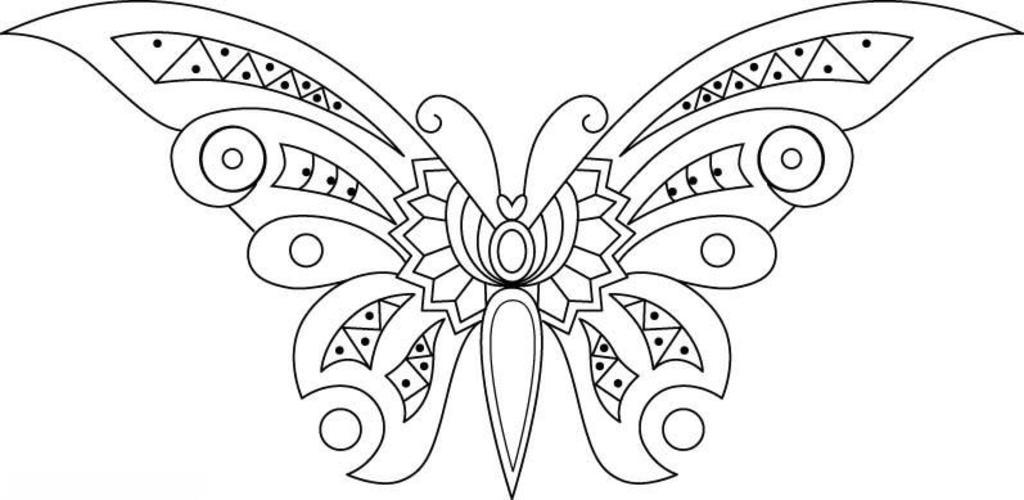What is depicted in the image? There is a sketch of a butterfly in the image. What type of linen is used to cover the cave in the image? There is no cave or linen present in the image; it features a sketch of a butterfly. How many books are visible in the image? There are no books present in the image; it features a sketch of a butterfly. 